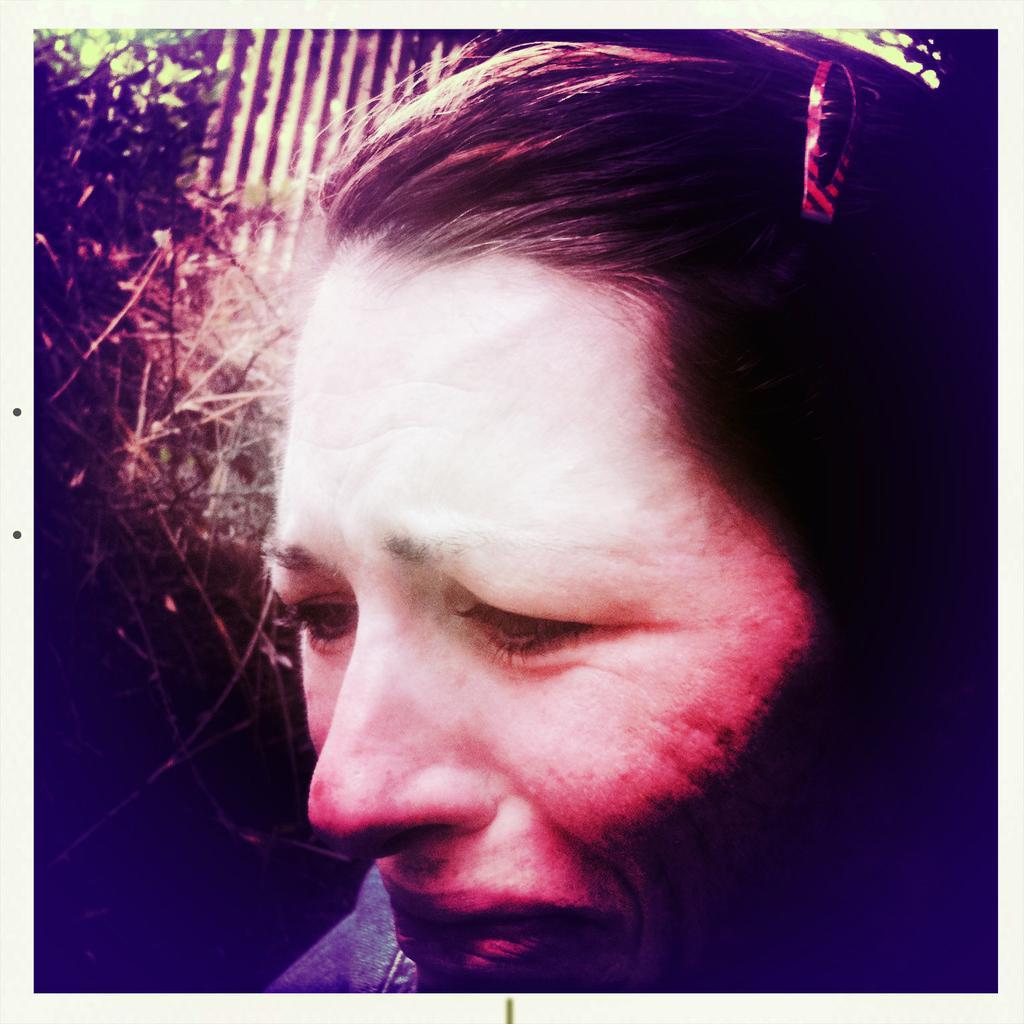Can you describe this image briefly? In the background we can see the green leaves and an object. In this picture we can see the branches and a person wearing a hair clip. it seems like the person is crying. 